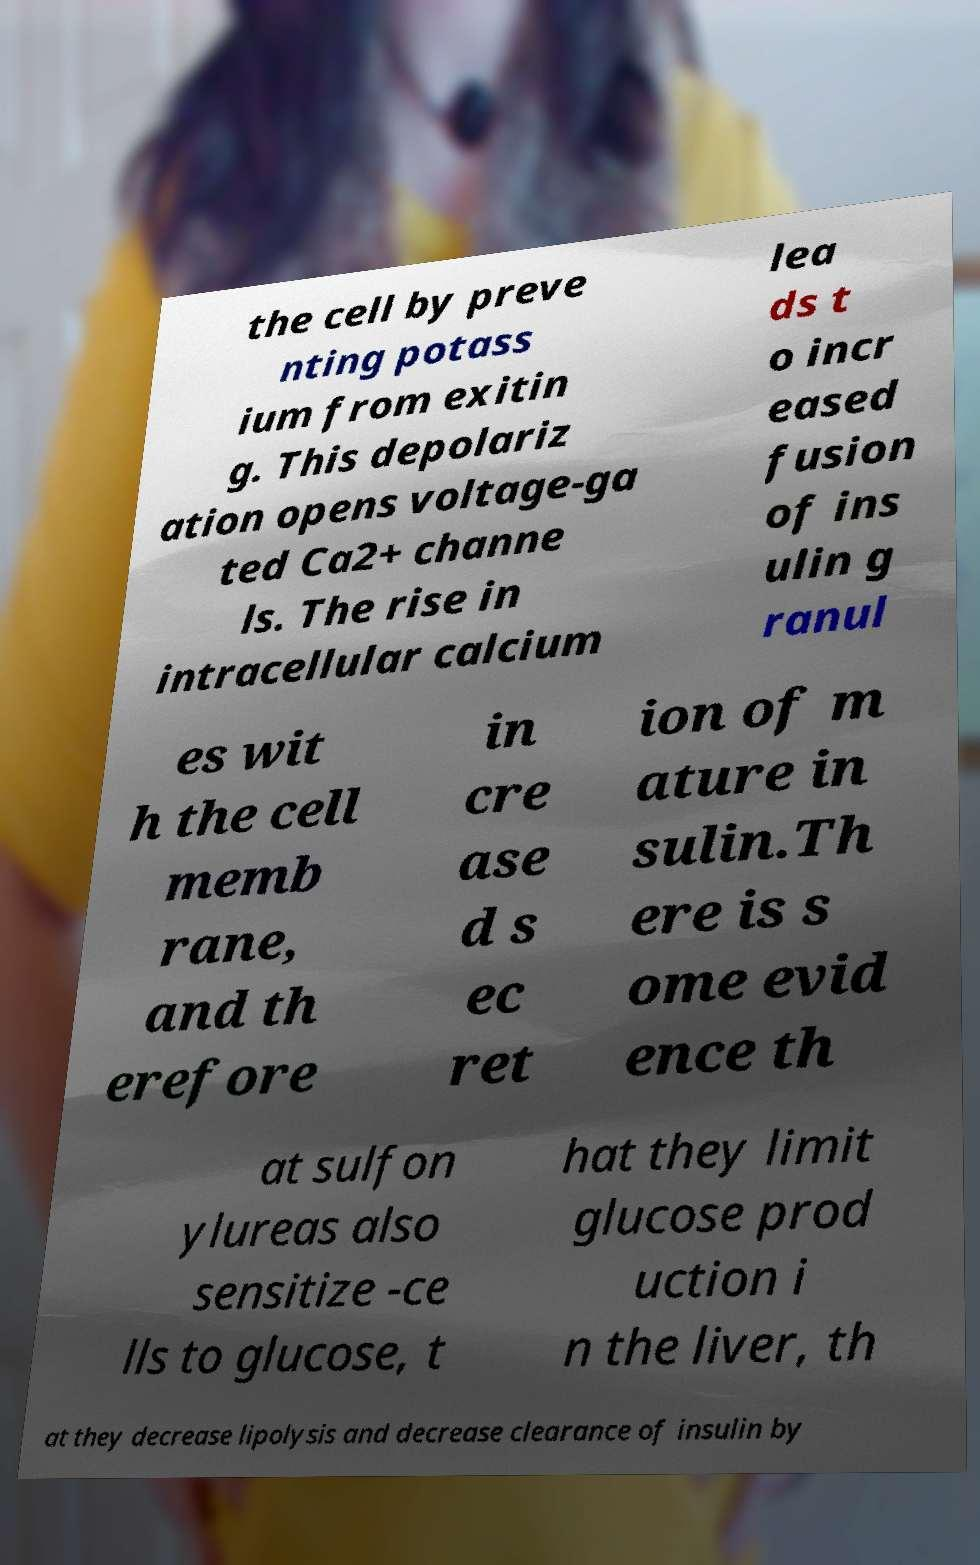Can you read and provide the text displayed in the image?This photo seems to have some interesting text. Can you extract and type it out for me? the cell by preve nting potass ium from exitin g. This depolariz ation opens voltage-ga ted Ca2+ channe ls. The rise in intracellular calcium lea ds t o incr eased fusion of ins ulin g ranul es wit h the cell memb rane, and th erefore in cre ase d s ec ret ion of m ature in sulin.Th ere is s ome evid ence th at sulfon ylureas also sensitize -ce lls to glucose, t hat they limit glucose prod uction i n the liver, th at they decrease lipolysis and decrease clearance of insulin by 